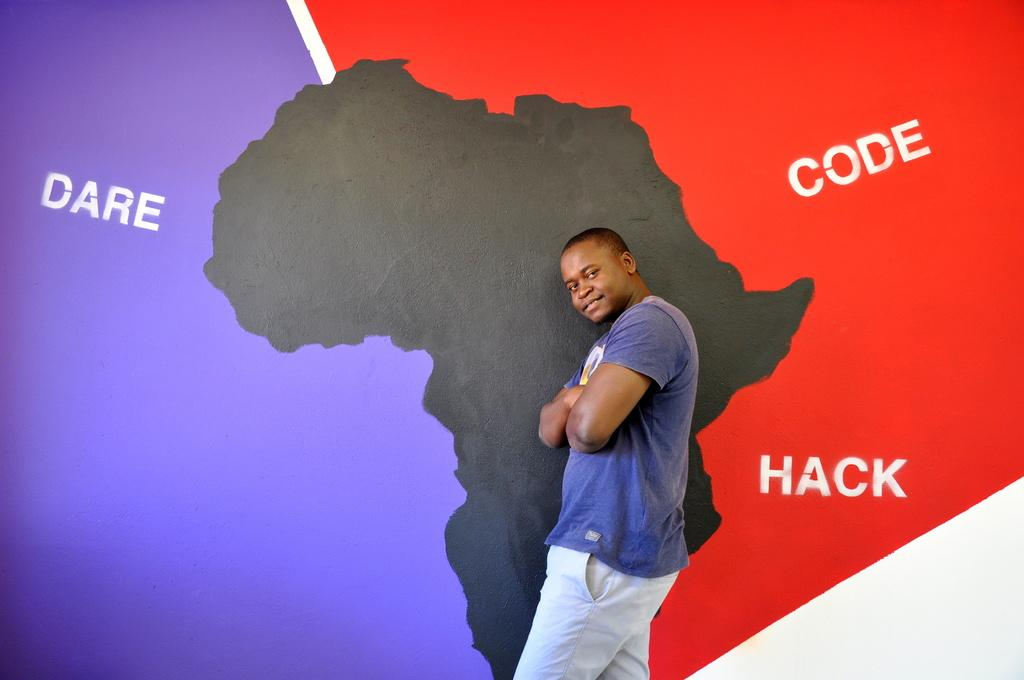<image>
Relay a brief, clear account of the picture shown. A guy in front of a picture of africa and the words Dare, code, and hack. 